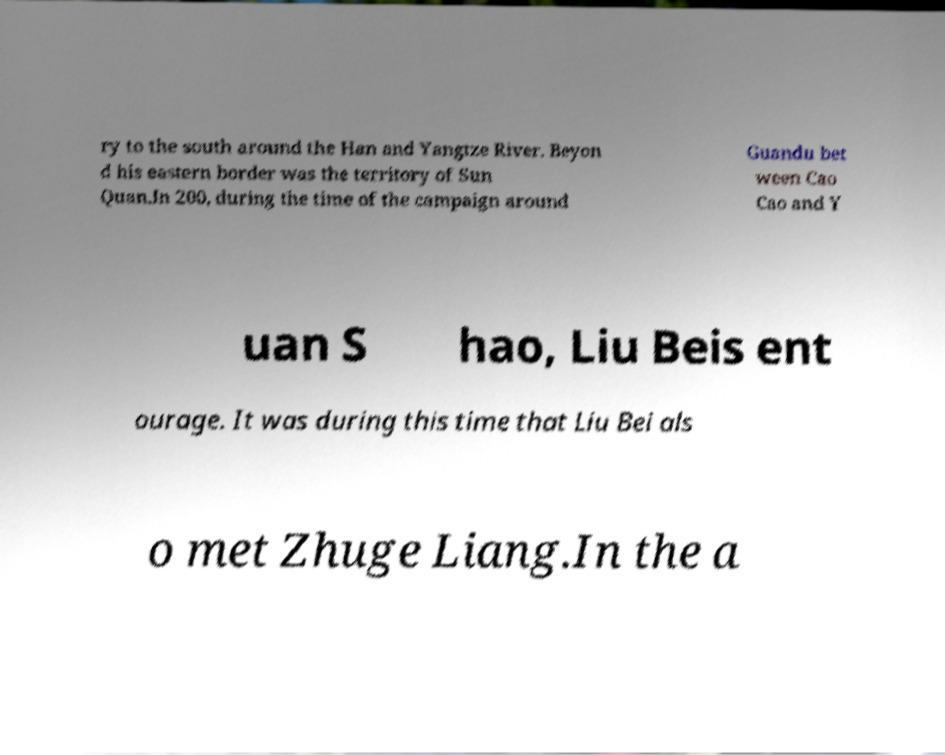Could you assist in decoding the text presented in this image and type it out clearly? ry to the south around the Han and Yangtze River. Beyon d his eastern border was the territory of Sun Quan.In 200, during the time of the campaign around Guandu bet ween Cao Cao and Y uan S hao, Liu Beis ent ourage. It was during this time that Liu Bei als o met Zhuge Liang.In the a 